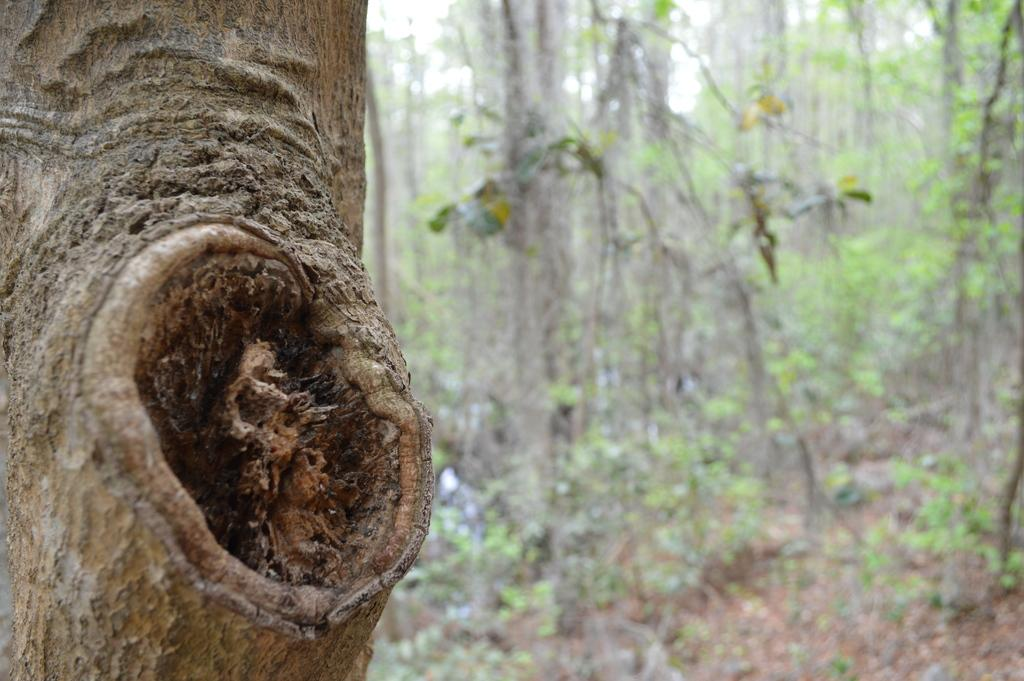What is the primary feature of the image? The primary feature of the image is the presence of many trees. Can you describe a specific tree in the image? Yes, there is a trunk of a tree at the right side of the image. What type of animal can be seen walking on the ground in the image? There are no animals visible in the image; it primarily features trees. Can you describe the room where the trees are located in the image? The image does not show a room; it is an outdoor scene with trees. 